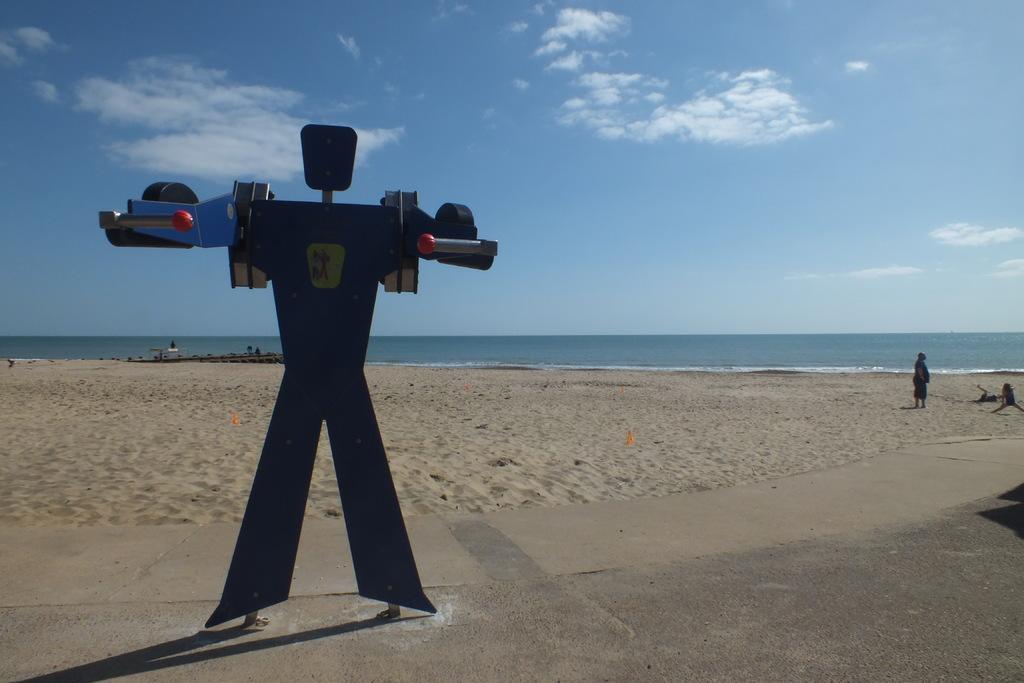In one or two sentences, can you explain what this image depicts? In the foreground I can see some object on the road and two persons on the beach. In the background I can see water and the sky. This image is taken may be on the sandy beach. 